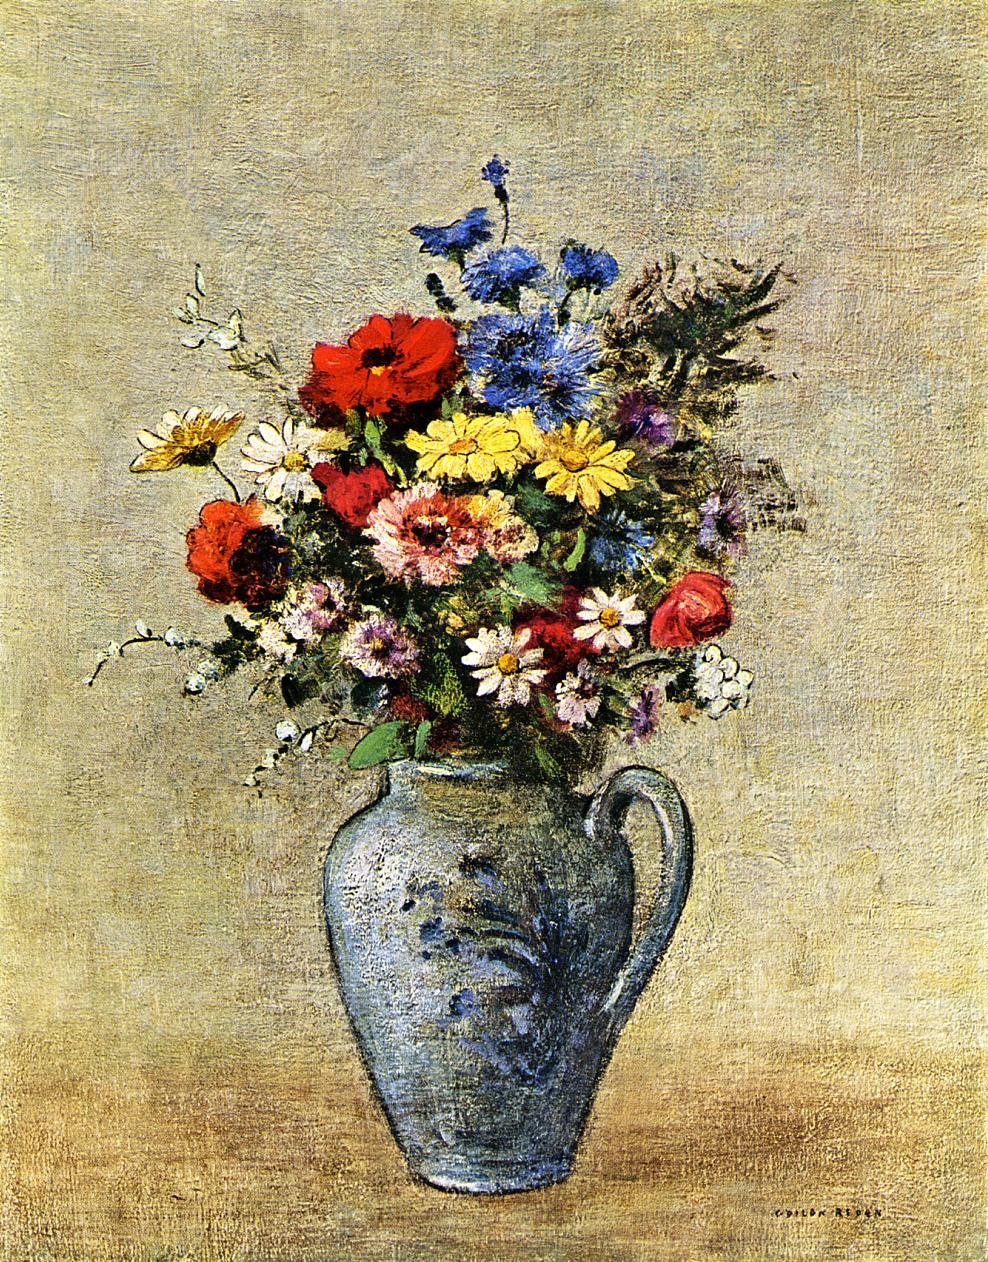How might this painting reflect the personal life or times of the artist? This painting could reflect a personal or cultural significance for the artist. The use of vibrant colors and dynamic composition may indicate a period of personal happiness or societal optimism. Alternatively, such a bouquet could represent remembrance or a tribute, perhaps indicating a personal loss or longing. Contextual analysis of the artist's other works and lifetime might provide deeper insights into the specific motivations behind this piece. 